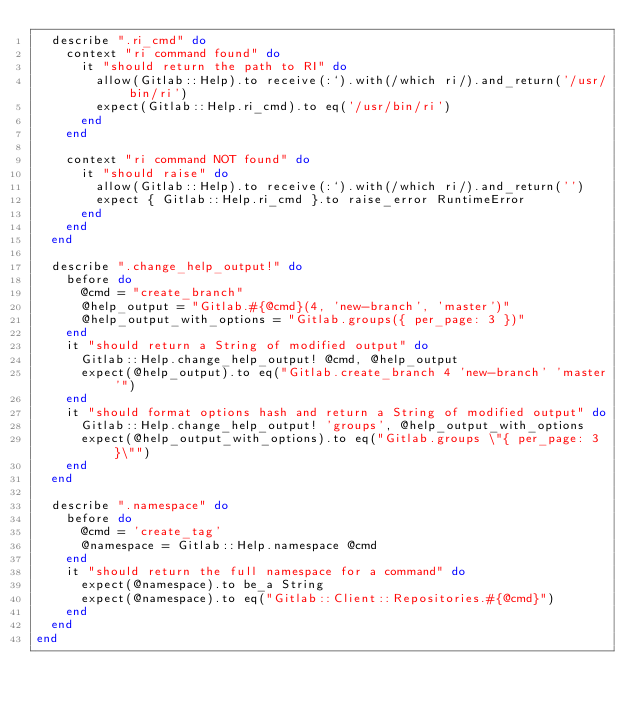<code> <loc_0><loc_0><loc_500><loc_500><_Ruby_>  describe ".ri_cmd" do
    context "ri command found" do
      it "should return the path to RI" do
        allow(Gitlab::Help).to receive(:`).with(/which ri/).and_return('/usr/bin/ri')
        expect(Gitlab::Help.ri_cmd).to eq('/usr/bin/ri')
      end
    end

    context "ri command NOT found" do
      it "should raise" do
        allow(Gitlab::Help).to receive(:`).with(/which ri/).and_return('')
        expect { Gitlab::Help.ri_cmd }.to raise_error RuntimeError
      end
    end
  end

  describe ".change_help_output!" do
    before do
      @cmd = "create_branch"
      @help_output = "Gitlab.#{@cmd}(4, 'new-branch', 'master')"
      @help_output_with_options = "Gitlab.groups({ per_page: 3 })"
    end
    it "should return a String of modified output" do
      Gitlab::Help.change_help_output! @cmd, @help_output
      expect(@help_output).to eq("Gitlab.create_branch 4 'new-branch' 'master'")
    end
    it "should format options hash and return a String of modified output" do
      Gitlab::Help.change_help_output! 'groups', @help_output_with_options
      expect(@help_output_with_options).to eq("Gitlab.groups \"{ per_page: 3 }\"")
    end
  end

  describe ".namespace" do
    before do
      @cmd = 'create_tag'
      @namespace = Gitlab::Help.namespace @cmd
    end
    it "should return the full namespace for a command" do
      expect(@namespace).to be_a String
      expect(@namespace).to eq("Gitlab::Client::Repositories.#{@cmd}")
    end
  end
end
</code> 